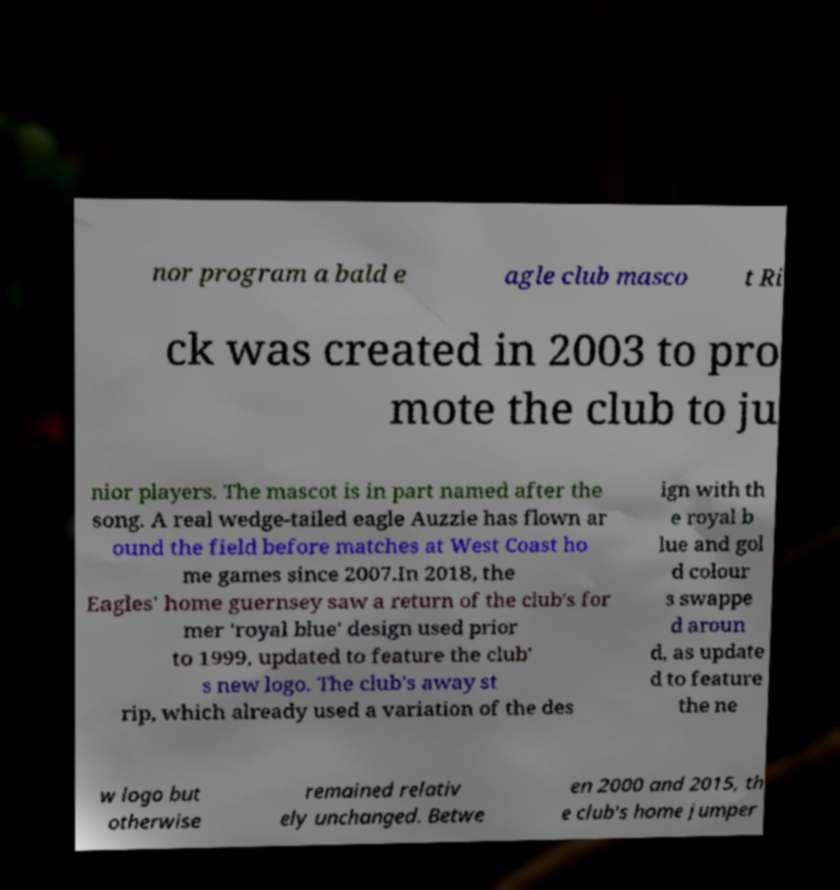Please read and relay the text visible in this image. What does it say? nor program a bald e agle club masco t Ri ck was created in 2003 to pro mote the club to ju nior players. The mascot is in part named after the song. A real wedge-tailed eagle Auzzie has flown ar ound the field before matches at West Coast ho me games since 2007.In 2018, the Eagles' home guernsey saw a return of the club's for mer 'royal blue' design used prior to 1999, updated to feature the club' s new logo. The club's away st rip, which already used a variation of the des ign with th e royal b lue and gol d colour s swappe d aroun d, as update d to feature the ne w logo but otherwise remained relativ ely unchanged. Betwe en 2000 and 2015, th e club's home jumper 